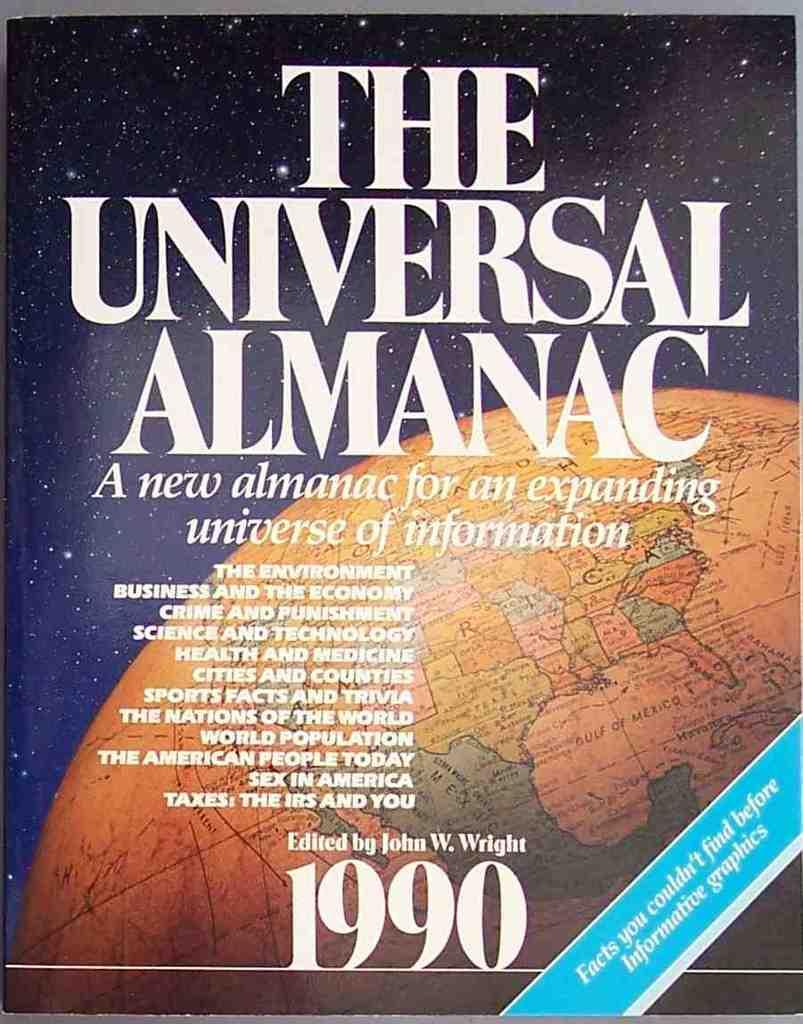<image>
Present a compact description of the photo's key features. The cover of the 1990 edition of The Universal Almanac. 